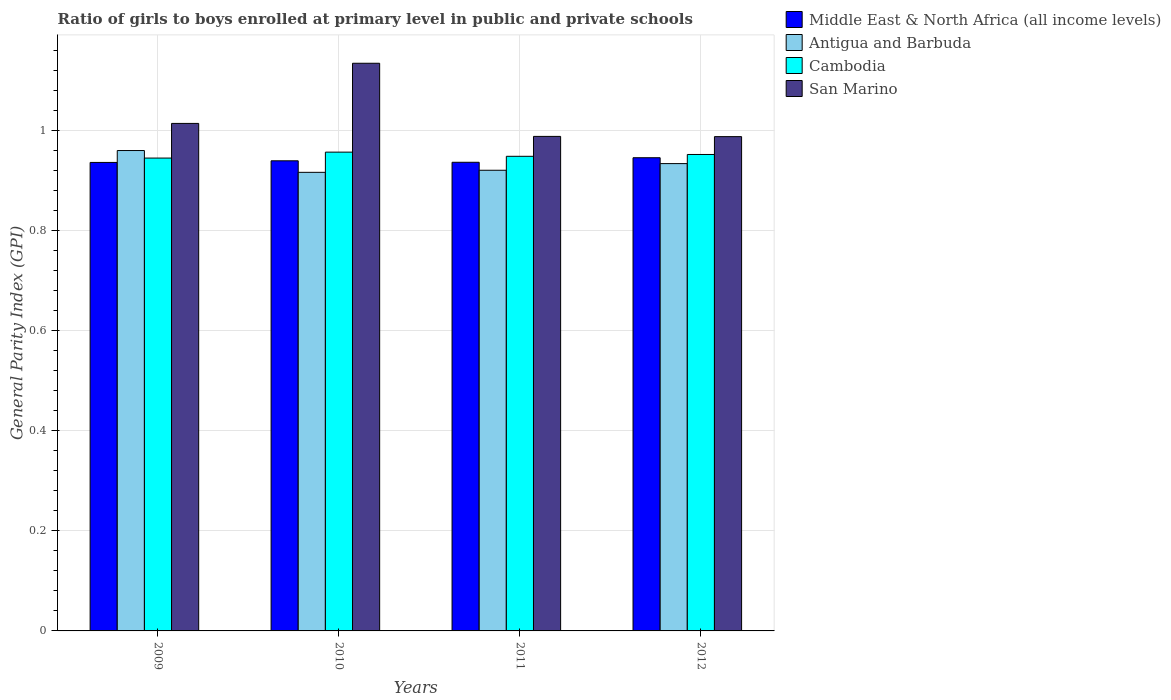How many groups of bars are there?
Offer a very short reply. 4. Are the number of bars per tick equal to the number of legend labels?
Your response must be concise. Yes. How many bars are there on the 3rd tick from the left?
Keep it short and to the point. 4. How many bars are there on the 4th tick from the right?
Offer a very short reply. 4. What is the label of the 4th group of bars from the left?
Ensure brevity in your answer.  2012. What is the general parity index in Middle East & North Africa (all income levels) in 2012?
Make the answer very short. 0.94. Across all years, what is the maximum general parity index in Middle East & North Africa (all income levels)?
Ensure brevity in your answer.  0.94. Across all years, what is the minimum general parity index in Cambodia?
Provide a succinct answer. 0.94. In which year was the general parity index in Antigua and Barbuda maximum?
Give a very brief answer. 2009. What is the total general parity index in Middle East & North Africa (all income levels) in the graph?
Offer a very short reply. 3.76. What is the difference between the general parity index in San Marino in 2009 and that in 2011?
Ensure brevity in your answer.  0.03. What is the difference between the general parity index in San Marino in 2010 and the general parity index in Cambodia in 2012?
Your answer should be compact. 0.18. What is the average general parity index in Cambodia per year?
Your response must be concise. 0.95. In the year 2010, what is the difference between the general parity index in Antigua and Barbuda and general parity index in San Marino?
Give a very brief answer. -0.22. What is the ratio of the general parity index in Antigua and Barbuda in 2009 to that in 2012?
Your answer should be compact. 1.03. Is the general parity index in San Marino in 2009 less than that in 2012?
Offer a very short reply. No. Is the difference between the general parity index in Antigua and Barbuda in 2010 and 2011 greater than the difference between the general parity index in San Marino in 2010 and 2011?
Your response must be concise. No. What is the difference between the highest and the second highest general parity index in Middle East & North Africa (all income levels)?
Give a very brief answer. 0.01. What is the difference between the highest and the lowest general parity index in Cambodia?
Ensure brevity in your answer.  0.01. Is the sum of the general parity index in San Marino in 2009 and 2010 greater than the maximum general parity index in Cambodia across all years?
Offer a terse response. Yes. What does the 1st bar from the left in 2009 represents?
Offer a terse response. Middle East & North Africa (all income levels). What does the 2nd bar from the right in 2009 represents?
Your response must be concise. Cambodia. Is it the case that in every year, the sum of the general parity index in Cambodia and general parity index in Middle East & North Africa (all income levels) is greater than the general parity index in Antigua and Barbuda?
Your answer should be very brief. Yes. How many years are there in the graph?
Offer a terse response. 4. Are the values on the major ticks of Y-axis written in scientific E-notation?
Your answer should be very brief. No. Does the graph contain grids?
Give a very brief answer. Yes. How many legend labels are there?
Provide a succinct answer. 4. How are the legend labels stacked?
Your response must be concise. Vertical. What is the title of the graph?
Provide a succinct answer. Ratio of girls to boys enrolled at primary level in public and private schools. What is the label or title of the X-axis?
Keep it short and to the point. Years. What is the label or title of the Y-axis?
Give a very brief answer. General Parity Index (GPI). What is the General Parity Index (GPI) in Middle East & North Africa (all income levels) in 2009?
Provide a succinct answer. 0.94. What is the General Parity Index (GPI) of Antigua and Barbuda in 2009?
Your answer should be very brief. 0.96. What is the General Parity Index (GPI) of Cambodia in 2009?
Keep it short and to the point. 0.94. What is the General Parity Index (GPI) of San Marino in 2009?
Make the answer very short. 1.01. What is the General Parity Index (GPI) in Middle East & North Africa (all income levels) in 2010?
Offer a very short reply. 0.94. What is the General Parity Index (GPI) in Antigua and Barbuda in 2010?
Provide a succinct answer. 0.92. What is the General Parity Index (GPI) of Cambodia in 2010?
Offer a very short reply. 0.96. What is the General Parity Index (GPI) in San Marino in 2010?
Give a very brief answer. 1.13. What is the General Parity Index (GPI) in Middle East & North Africa (all income levels) in 2011?
Make the answer very short. 0.94. What is the General Parity Index (GPI) of Antigua and Barbuda in 2011?
Provide a short and direct response. 0.92. What is the General Parity Index (GPI) in Cambodia in 2011?
Your answer should be compact. 0.95. What is the General Parity Index (GPI) in San Marino in 2011?
Keep it short and to the point. 0.99. What is the General Parity Index (GPI) of Middle East & North Africa (all income levels) in 2012?
Ensure brevity in your answer.  0.94. What is the General Parity Index (GPI) in Antigua and Barbuda in 2012?
Your answer should be compact. 0.93. What is the General Parity Index (GPI) in Cambodia in 2012?
Provide a short and direct response. 0.95. What is the General Parity Index (GPI) in San Marino in 2012?
Provide a short and direct response. 0.99. Across all years, what is the maximum General Parity Index (GPI) of Middle East & North Africa (all income levels)?
Give a very brief answer. 0.94. Across all years, what is the maximum General Parity Index (GPI) in Antigua and Barbuda?
Your response must be concise. 0.96. Across all years, what is the maximum General Parity Index (GPI) in Cambodia?
Make the answer very short. 0.96. Across all years, what is the maximum General Parity Index (GPI) of San Marino?
Ensure brevity in your answer.  1.13. Across all years, what is the minimum General Parity Index (GPI) of Middle East & North Africa (all income levels)?
Provide a succinct answer. 0.94. Across all years, what is the minimum General Parity Index (GPI) of Antigua and Barbuda?
Your answer should be very brief. 0.92. Across all years, what is the minimum General Parity Index (GPI) of Cambodia?
Your response must be concise. 0.94. Across all years, what is the minimum General Parity Index (GPI) of San Marino?
Keep it short and to the point. 0.99. What is the total General Parity Index (GPI) in Middle East & North Africa (all income levels) in the graph?
Make the answer very short. 3.76. What is the total General Parity Index (GPI) in Antigua and Barbuda in the graph?
Keep it short and to the point. 3.73. What is the total General Parity Index (GPI) of Cambodia in the graph?
Your response must be concise. 3.8. What is the total General Parity Index (GPI) in San Marino in the graph?
Provide a short and direct response. 4.12. What is the difference between the General Parity Index (GPI) in Middle East & North Africa (all income levels) in 2009 and that in 2010?
Keep it short and to the point. -0. What is the difference between the General Parity Index (GPI) of Antigua and Barbuda in 2009 and that in 2010?
Offer a very short reply. 0.04. What is the difference between the General Parity Index (GPI) of Cambodia in 2009 and that in 2010?
Your response must be concise. -0.01. What is the difference between the General Parity Index (GPI) of San Marino in 2009 and that in 2010?
Provide a succinct answer. -0.12. What is the difference between the General Parity Index (GPI) of Middle East & North Africa (all income levels) in 2009 and that in 2011?
Keep it short and to the point. -0. What is the difference between the General Parity Index (GPI) of Antigua and Barbuda in 2009 and that in 2011?
Make the answer very short. 0.04. What is the difference between the General Parity Index (GPI) in Cambodia in 2009 and that in 2011?
Offer a terse response. -0. What is the difference between the General Parity Index (GPI) of San Marino in 2009 and that in 2011?
Your answer should be very brief. 0.03. What is the difference between the General Parity Index (GPI) of Middle East & North Africa (all income levels) in 2009 and that in 2012?
Offer a very short reply. -0.01. What is the difference between the General Parity Index (GPI) in Antigua and Barbuda in 2009 and that in 2012?
Offer a terse response. 0.03. What is the difference between the General Parity Index (GPI) of Cambodia in 2009 and that in 2012?
Provide a succinct answer. -0.01. What is the difference between the General Parity Index (GPI) in San Marino in 2009 and that in 2012?
Your response must be concise. 0.03. What is the difference between the General Parity Index (GPI) of Middle East & North Africa (all income levels) in 2010 and that in 2011?
Provide a succinct answer. 0. What is the difference between the General Parity Index (GPI) of Antigua and Barbuda in 2010 and that in 2011?
Offer a very short reply. -0. What is the difference between the General Parity Index (GPI) in Cambodia in 2010 and that in 2011?
Provide a succinct answer. 0.01. What is the difference between the General Parity Index (GPI) of San Marino in 2010 and that in 2011?
Offer a very short reply. 0.15. What is the difference between the General Parity Index (GPI) of Middle East & North Africa (all income levels) in 2010 and that in 2012?
Your response must be concise. -0.01. What is the difference between the General Parity Index (GPI) of Antigua and Barbuda in 2010 and that in 2012?
Provide a short and direct response. -0.02. What is the difference between the General Parity Index (GPI) of Cambodia in 2010 and that in 2012?
Offer a very short reply. 0. What is the difference between the General Parity Index (GPI) in San Marino in 2010 and that in 2012?
Offer a very short reply. 0.15. What is the difference between the General Parity Index (GPI) of Middle East & North Africa (all income levels) in 2011 and that in 2012?
Keep it short and to the point. -0.01. What is the difference between the General Parity Index (GPI) of Antigua and Barbuda in 2011 and that in 2012?
Offer a very short reply. -0.01. What is the difference between the General Parity Index (GPI) in Cambodia in 2011 and that in 2012?
Make the answer very short. -0. What is the difference between the General Parity Index (GPI) of San Marino in 2011 and that in 2012?
Provide a short and direct response. 0. What is the difference between the General Parity Index (GPI) of Middle East & North Africa (all income levels) in 2009 and the General Parity Index (GPI) of Antigua and Barbuda in 2010?
Provide a succinct answer. 0.02. What is the difference between the General Parity Index (GPI) in Middle East & North Africa (all income levels) in 2009 and the General Parity Index (GPI) in Cambodia in 2010?
Keep it short and to the point. -0.02. What is the difference between the General Parity Index (GPI) of Middle East & North Africa (all income levels) in 2009 and the General Parity Index (GPI) of San Marino in 2010?
Ensure brevity in your answer.  -0.2. What is the difference between the General Parity Index (GPI) of Antigua and Barbuda in 2009 and the General Parity Index (GPI) of Cambodia in 2010?
Provide a succinct answer. 0. What is the difference between the General Parity Index (GPI) in Antigua and Barbuda in 2009 and the General Parity Index (GPI) in San Marino in 2010?
Your response must be concise. -0.17. What is the difference between the General Parity Index (GPI) in Cambodia in 2009 and the General Parity Index (GPI) in San Marino in 2010?
Your answer should be very brief. -0.19. What is the difference between the General Parity Index (GPI) in Middle East & North Africa (all income levels) in 2009 and the General Parity Index (GPI) in Antigua and Barbuda in 2011?
Ensure brevity in your answer.  0.02. What is the difference between the General Parity Index (GPI) in Middle East & North Africa (all income levels) in 2009 and the General Parity Index (GPI) in Cambodia in 2011?
Your answer should be very brief. -0.01. What is the difference between the General Parity Index (GPI) of Middle East & North Africa (all income levels) in 2009 and the General Parity Index (GPI) of San Marino in 2011?
Provide a short and direct response. -0.05. What is the difference between the General Parity Index (GPI) of Antigua and Barbuda in 2009 and the General Parity Index (GPI) of Cambodia in 2011?
Provide a short and direct response. 0.01. What is the difference between the General Parity Index (GPI) of Antigua and Barbuda in 2009 and the General Parity Index (GPI) of San Marino in 2011?
Make the answer very short. -0.03. What is the difference between the General Parity Index (GPI) of Cambodia in 2009 and the General Parity Index (GPI) of San Marino in 2011?
Offer a very short reply. -0.04. What is the difference between the General Parity Index (GPI) of Middle East & North Africa (all income levels) in 2009 and the General Parity Index (GPI) of Antigua and Barbuda in 2012?
Give a very brief answer. 0. What is the difference between the General Parity Index (GPI) of Middle East & North Africa (all income levels) in 2009 and the General Parity Index (GPI) of Cambodia in 2012?
Make the answer very short. -0.02. What is the difference between the General Parity Index (GPI) of Middle East & North Africa (all income levels) in 2009 and the General Parity Index (GPI) of San Marino in 2012?
Provide a succinct answer. -0.05. What is the difference between the General Parity Index (GPI) of Antigua and Barbuda in 2009 and the General Parity Index (GPI) of Cambodia in 2012?
Make the answer very short. 0.01. What is the difference between the General Parity Index (GPI) of Antigua and Barbuda in 2009 and the General Parity Index (GPI) of San Marino in 2012?
Your answer should be compact. -0.03. What is the difference between the General Parity Index (GPI) in Cambodia in 2009 and the General Parity Index (GPI) in San Marino in 2012?
Your answer should be very brief. -0.04. What is the difference between the General Parity Index (GPI) in Middle East & North Africa (all income levels) in 2010 and the General Parity Index (GPI) in Antigua and Barbuda in 2011?
Provide a succinct answer. 0.02. What is the difference between the General Parity Index (GPI) in Middle East & North Africa (all income levels) in 2010 and the General Parity Index (GPI) in Cambodia in 2011?
Offer a very short reply. -0.01. What is the difference between the General Parity Index (GPI) of Middle East & North Africa (all income levels) in 2010 and the General Parity Index (GPI) of San Marino in 2011?
Keep it short and to the point. -0.05. What is the difference between the General Parity Index (GPI) of Antigua and Barbuda in 2010 and the General Parity Index (GPI) of Cambodia in 2011?
Offer a terse response. -0.03. What is the difference between the General Parity Index (GPI) of Antigua and Barbuda in 2010 and the General Parity Index (GPI) of San Marino in 2011?
Provide a short and direct response. -0.07. What is the difference between the General Parity Index (GPI) of Cambodia in 2010 and the General Parity Index (GPI) of San Marino in 2011?
Provide a short and direct response. -0.03. What is the difference between the General Parity Index (GPI) in Middle East & North Africa (all income levels) in 2010 and the General Parity Index (GPI) in Antigua and Barbuda in 2012?
Your response must be concise. 0.01. What is the difference between the General Parity Index (GPI) in Middle East & North Africa (all income levels) in 2010 and the General Parity Index (GPI) in Cambodia in 2012?
Your response must be concise. -0.01. What is the difference between the General Parity Index (GPI) of Middle East & North Africa (all income levels) in 2010 and the General Parity Index (GPI) of San Marino in 2012?
Offer a very short reply. -0.05. What is the difference between the General Parity Index (GPI) of Antigua and Barbuda in 2010 and the General Parity Index (GPI) of Cambodia in 2012?
Your response must be concise. -0.04. What is the difference between the General Parity Index (GPI) of Antigua and Barbuda in 2010 and the General Parity Index (GPI) of San Marino in 2012?
Keep it short and to the point. -0.07. What is the difference between the General Parity Index (GPI) of Cambodia in 2010 and the General Parity Index (GPI) of San Marino in 2012?
Keep it short and to the point. -0.03. What is the difference between the General Parity Index (GPI) in Middle East & North Africa (all income levels) in 2011 and the General Parity Index (GPI) in Antigua and Barbuda in 2012?
Keep it short and to the point. 0. What is the difference between the General Parity Index (GPI) in Middle East & North Africa (all income levels) in 2011 and the General Parity Index (GPI) in Cambodia in 2012?
Offer a terse response. -0.02. What is the difference between the General Parity Index (GPI) of Middle East & North Africa (all income levels) in 2011 and the General Parity Index (GPI) of San Marino in 2012?
Make the answer very short. -0.05. What is the difference between the General Parity Index (GPI) in Antigua and Barbuda in 2011 and the General Parity Index (GPI) in Cambodia in 2012?
Provide a short and direct response. -0.03. What is the difference between the General Parity Index (GPI) in Antigua and Barbuda in 2011 and the General Parity Index (GPI) in San Marino in 2012?
Your answer should be very brief. -0.07. What is the difference between the General Parity Index (GPI) of Cambodia in 2011 and the General Parity Index (GPI) of San Marino in 2012?
Give a very brief answer. -0.04. What is the average General Parity Index (GPI) of Middle East & North Africa (all income levels) per year?
Offer a very short reply. 0.94. What is the average General Parity Index (GPI) in Antigua and Barbuda per year?
Your response must be concise. 0.93. What is the average General Parity Index (GPI) in Cambodia per year?
Ensure brevity in your answer.  0.95. What is the average General Parity Index (GPI) of San Marino per year?
Provide a succinct answer. 1.03. In the year 2009, what is the difference between the General Parity Index (GPI) in Middle East & North Africa (all income levels) and General Parity Index (GPI) in Antigua and Barbuda?
Your answer should be very brief. -0.02. In the year 2009, what is the difference between the General Parity Index (GPI) in Middle East & North Africa (all income levels) and General Parity Index (GPI) in Cambodia?
Your answer should be compact. -0.01. In the year 2009, what is the difference between the General Parity Index (GPI) of Middle East & North Africa (all income levels) and General Parity Index (GPI) of San Marino?
Your answer should be compact. -0.08. In the year 2009, what is the difference between the General Parity Index (GPI) in Antigua and Barbuda and General Parity Index (GPI) in Cambodia?
Offer a very short reply. 0.01. In the year 2009, what is the difference between the General Parity Index (GPI) of Antigua and Barbuda and General Parity Index (GPI) of San Marino?
Ensure brevity in your answer.  -0.05. In the year 2009, what is the difference between the General Parity Index (GPI) of Cambodia and General Parity Index (GPI) of San Marino?
Your answer should be compact. -0.07. In the year 2010, what is the difference between the General Parity Index (GPI) of Middle East & North Africa (all income levels) and General Parity Index (GPI) of Antigua and Barbuda?
Keep it short and to the point. 0.02. In the year 2010, what is the difference between the General Parity Index (GPI) in Middle East & North Africa (all income levels) and General Parity Index (GPI) in Cambodia?
Make the answer very short. -0.02. In the year 2010, what is the difference between the General Parity Index (GPI) in Middle East & North Africa (all income levels) and General Parity Index (GPI) in San Marino?
Provide a short and direct response. -0.19. In the year 2010, what is the difference between the General Parity Index (GPI) of Antigua and Barbuda and General Parity Index (GPI) of Cambodia?
Provide a succinct answer. -0.04. In the year 2010, what is the difference between the General Parity Index (GPI) in Antigua and Barbuda and General Parity Index (GPI) in San Marino?
Your answer should be very brief. -0.22. In the year 2010, what is the difference between the General Parity Index (GPI) in Cambodia and General Parity Index (GPI) in San Marino?
Offer a very short reply. -0.18. In the year 2011, what is the difference between the General Parity Index (GPI) of Middle East & North Africa (all income levels) and General Parity Index (GPI) of Antigua and Barbuda?
Your answer should be very brief. 0.02. In the year 2011, what is the difference between the General Parity Index (GPI) in Middle East & North Africa (all income levels) and General Parity Index (GPI) in Cambodia?
Offer a very short reply. -0.01. In the year 2011, what is the difference between the General Parity Index (GPI) of Middle East & North Africa (all income levels) and General Parity Index (GPI) of San Marino?
Your answer should be compact. -0.05. In the year 2011, what is the difference between the General Parity Index (GPI) in Antigua and Barbuda and General Parity Index (GPI) in Cambodia?
Provide a succinct answer. -0.03. In the year 2011, what is the difference between the General Parity Index (GPI) of Antigua and Barbuda and General Parity Index (GPI) of San Marino?
Make the answer very short. -0.07. In the year 2011, what is the difference between the General Parity Index (GPI) in Cambodia and General Parity Index (GPI) in San Marino?
Offer a very short reply. -0.04. In the year 2012, what is the difference between the General Parity Index (GPI) of Middle East & North Africa (all income levels) and General Parity Index (GPI) of Antigua and Barbuda?
Keep it short and to the point. 0.01. In the year 2012, what is the difference between the General Parity Index (GPI) in Middle East & North Africa (all income levels) and General Parity Index (GPI) in Cambodia?
Ensure brevity in your answer.  -0.01. In the year 2012, what is the difference between the General Parity Index (GPI) of Middle East & North Africa (all income levels) and General Parity Index (GPI) of San Marino?
Keep it short and to the point. -0.04. In the year 2012, what is the difference between the General Parity Index (GPI) of Antigua and Barbuda and General Parity Index (GPI) of Cambodia?
Your answer should be very brief. -0.02. In the year 2012, what is the difference between the General Parity Index (GPI) in Antigua and Barbuda and General Parity Index (GPI) in San Marino?
Make the answer very short. -0.05. In the year 2012, what is the difference between the General Parity Index (GPI) of Cambodia and General Parity Index (GPI) of San Marino?
Keep it short and to the point. -0.04. What is the ratio of the General Parity Index (GPI) of Antigua and Barbuda in 2009 to that in 2010?
Offer a very short reply. 1.05. What is the ratio of the General Parity Index (GPI) of Cambodia in 2009 to that in 2010?
Keep it short and to the point. 0.99. What is the ratio of the General Parity Index (GPI) of San Marino in 2009 to that in 2010?
Keep it short and to the point. 0.89. What is the ratio of the General Parity Index (GPI) in Middle East & North Africa (all income levels) in 2009 to that in 2011?
Make the answer very short. 1. What is the ratio of the General Parity Index (GPI) in Antigua and Barbuda in 2009 to that in 2011?
Offer a terse response. 1.04. What is the ratio of the General Parity Index (GPI) of San Marino in 2009 to that in 2011?
Your answer should be very brief. 1.03. What is the ratio of the General Parity Index (GPI) in Antigua and Barbuda in 2009 to that in 2012?
Offer a very short reply. 1.03. What is the ratio of the General Parity Index (GPI) of San Marino in 2009 to that in 2012?
Your response must be concise. 1.03. What is the ratio of the General Parity Index (GPI) in Middle East & North Africa (all income levels) in 2010 to that in 2011?
Offer a terse response. 1. What is the ratio of the General Parity Index (GPI) in Cambodia in 2010 to that in 2011?
Provide a succinct answer. 1.01. What is the ratio of the General Parity Index (GPI) of San Marino in 2010 to that in 2011?
Keep it short and to the point. 1.15. What is the ratio of the General Parity Index (GPI) of Antigua and Barbuda in 2010 to that in 2012?
Ensure brevity in your answer.  0.98. What is the ratio of the General Parity Index (GPI) of San Marino in 2010 to that in 2012?
Offer a terse response. 1.15. What is the ratio of the General Parity Index (GPI) of Middle East & North Africa (all income levels) in 2011 to that in 2012?
Your response must be concise. 0.99. What is the ratio of the General Parity Index (GPI) in Antigua and Barbuda in 2011 to that in 2012?
Your response must be concise. 0.99. What is the ratio of the General Parity Index (GPI) of San Marino in 2011 to that in 2012?
Keep it short and to the point. 1. What is the difference between the highest and the second highest General Parity Index (GPI) in Middle East & North Africa (all income levels)?
Provide a short and direct response. 0.01. What is the difference between the highest and the second highest General Parity Index (GPI) of Antigua and Barbuda?
Your answer should be compact. 0.03. What is the difference between the highest and the second highest General Parity Index (GPI) in Cambodia?
Offer a very short reply. 0. What is the difference between the highest and the second highest General Parity Index (GPI) in San Marino?
Provide a short and direct response. 0.12. What is the difference between the highest and the lowest General Parity Index (GPI) of Middle East & North Africa (all income levels)?
Ensure brevity in your answer.  0.01. What is the difference between the highest and the lowest General Parity Index (GPI) in Antigua and Barbuda?
Keep it short and to the point. 0.04. What is the difference between the highest and the lowest General Parity Index (GPI) in Cambodia?
Offer a very short reply. 0.01. What is the difference between the highest and the lowest General Parity Index (GPI) of San Marino?
Ensure brevity in your answer.  0.15. 